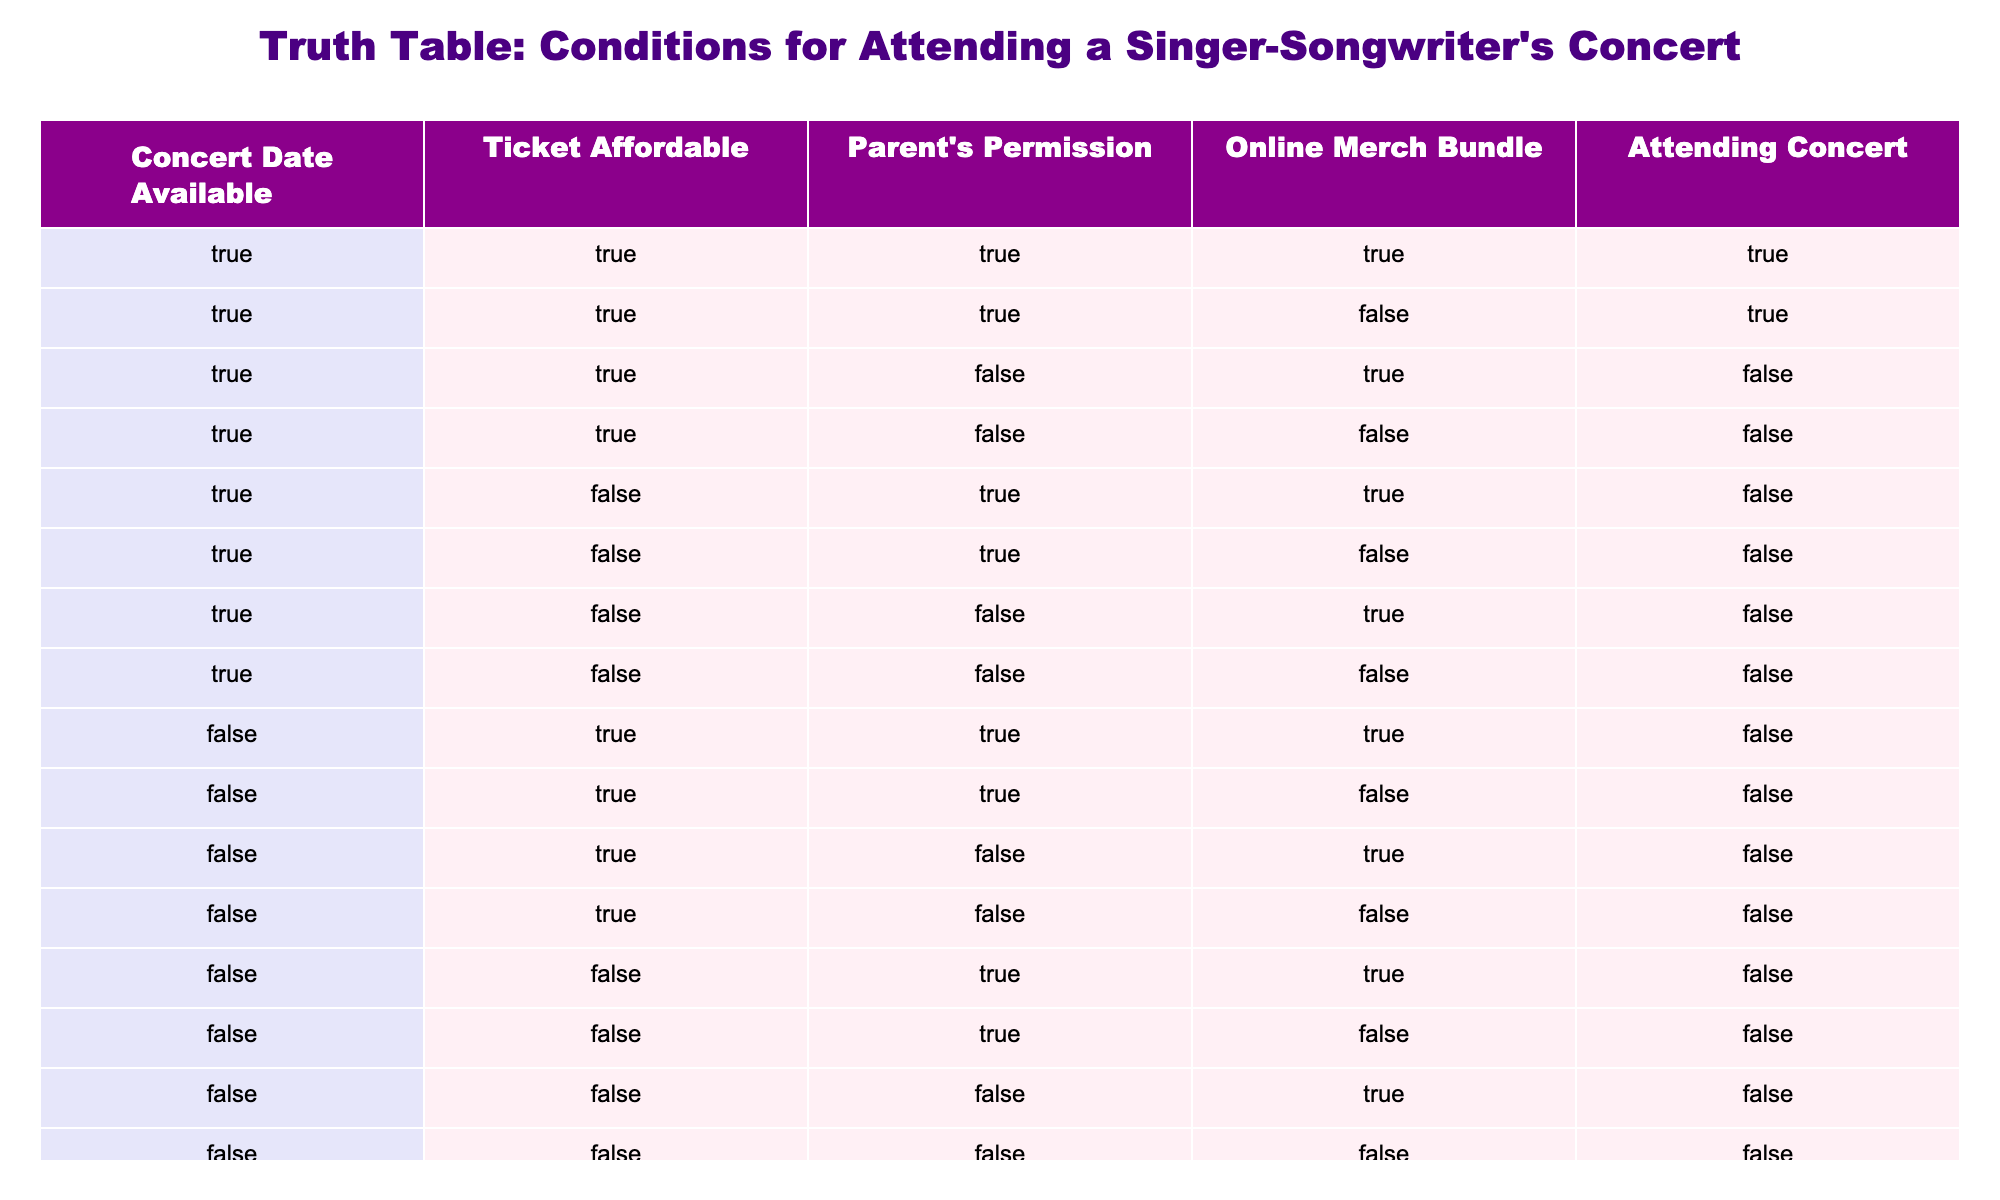What are the conditions under which I can attend the concert? The table shows the conditions needed for attending the concert, which are: Concert Date is available, Ticket is affordable, Parent's Permission is granted, and an Online Merch Bundle is included. If all these conditions are True, then attendance is True.
Answer: All conditions must be True How many times is attending the concert marked as True when the Ticket is not Affordable? By reviewing the table, we can count the instances where the Ticket is marked as False (affordable) and see how many of these instances have attending marked as True. There are no instances with Ticket as False and attending as True, so the total is 0.
Answer: 0 Is there a situation where attending the concert is possible with an unavailable Concert Date? Looking at the rows where the Concert Date is marked as False, attending is marked as False in all these rows. Therefore, there is no situation where attending the concert is possible if the Concert Date is unavailable.
Answer: No What is the total number of conditions where Online Merch Bundle was included and attending the concert was unsuccessful? We need to check how many times Online Merch Bundle is True while attending the concert is False. By examining the table, we find 4 instances that meet this criterion where Online Merch Bundle is True (specifically rows 3, 5, 12, and 15).
Answer: 4 If the Ticket becomes affordable, what is the maximum number of conditions that would allow me to attend the concert? By setting Ticket as True, we need to find all combinations of the other three conditions (Concert Date, Parent's Permission, Online Merch Bundle), which leads to a maximum of 4 conditions from rows with the Ticket as True (only considering combinations that make attending True). The maximum here is 4 distinct instances of True.
Answer: 4 